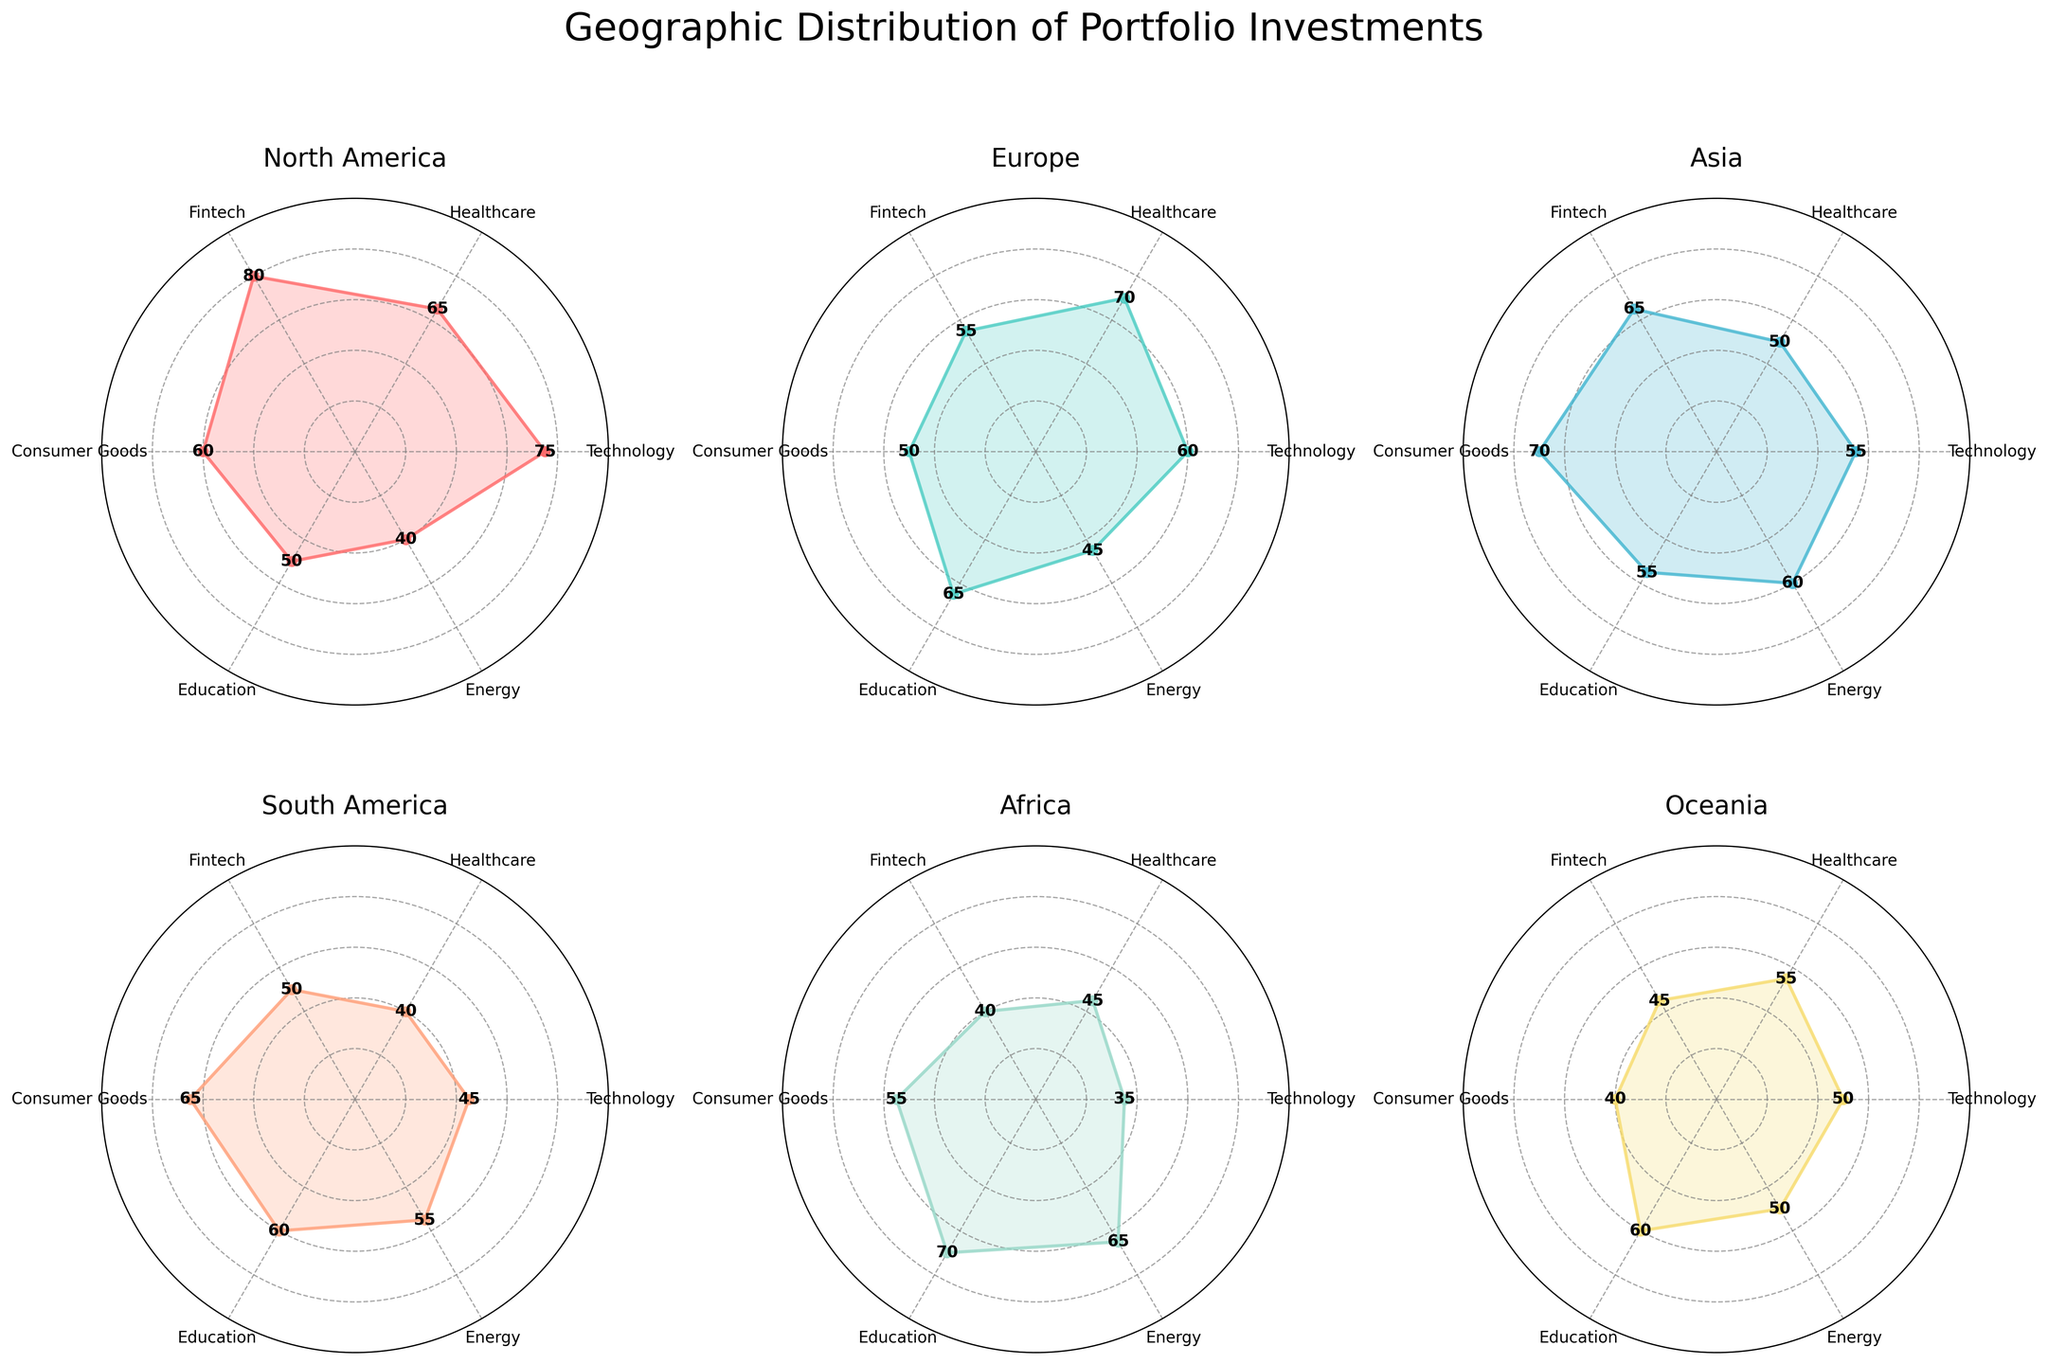What's the title of the figure? The title of the figure is located at the top center and usually indicates the main subject of the visualization.
Answer: Geographic Distribution of Portfolio Investments Which region has the highest investment in Technology? From the subplots, observe the angle representing Technology and identify which region's radar plot reaches the highest value at this angle. For Technology, North America's value is the highest at 75.
Answer: North America What is the average investment in Healthcare across all regions? Sum up the Healthcare values for each region (65 + 70 + 50 + 40 + 45 + 55) to get 325, and then divide by the number of regions (6): 325 / 6 = approximately 54.17.
Answer: 54.17 Which two regions have the closest investment values in Consumer Goods? Find the Consumer Goods values from each subplot and compare them: North America (60), Europe (50), Asia (70), South America (65), Africa (55), Oceania (40). Africa and Europe have the closest values (55 and 50).
Answer: Africa and Europe What is the total investment in Fintech for South America and Africa combined? Identify Fintech values for South America (50) and Africa (40), then add them together: 50 + 40 = 90.
Answer: 90 How does North America's investment in Energy compare to Asia's? North America's Energy investment is at 40, while Asia's is at 60. North America has a lower investment in Energy compared to Asia.
Answer: Lower Which region has the most balanced investment across the categories? The most balanced investment would have values closest to each other. Africa's values (35, 45, 40, 55, 70, 65) appear to be the most evenly spread.
Answer: Africa What is the range of Education investment values across all regions? Identify the Education values for each region: North America (50), Europe (65), Asia (55), South America (60), Africa (70), Oceania (60). The range is the difference between the highest (70) and lowest (50) values: 70 - 50 = 20.
Answer: 20 Which regions have more than 60% investment in at least one category? Check each region’s investment values; if any category has a value above 60: North America (Technology, Fintech), Europe (Healthcare), Asia (Consumer Goods, Energy), South America (Consumer Goods, Education), and Africa (Education).
Answer: North America, Europe, Asia, South America, Africa 